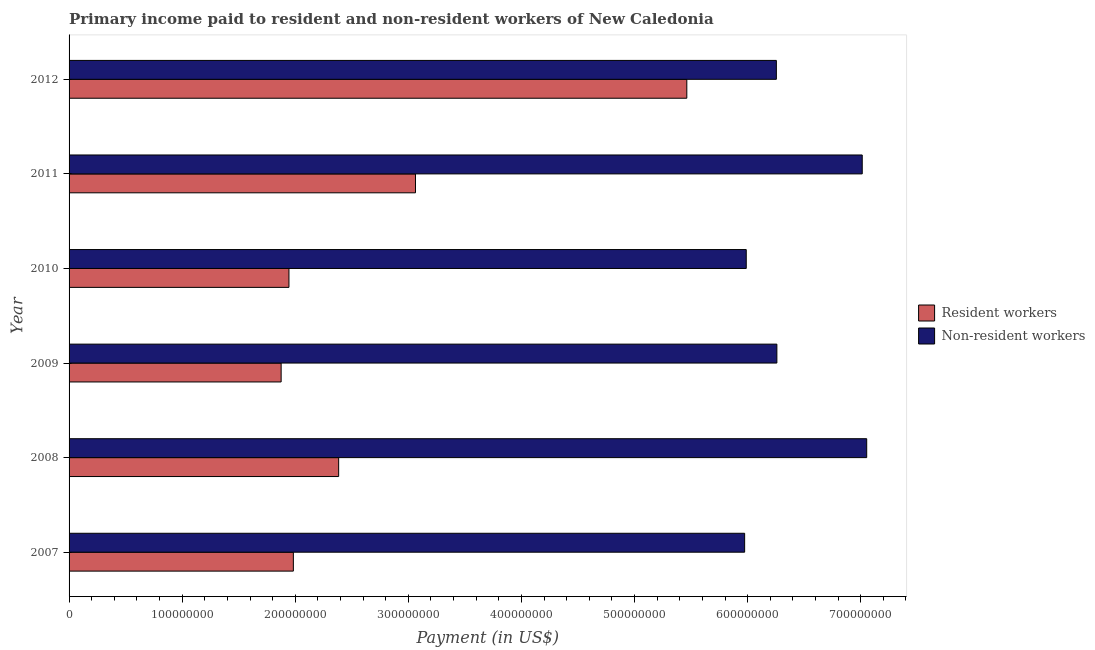How many different coloured bars are there?
Offer a very short reply. 2. How many groups of bars are there?
Give a very brief answer. 6. Are the number of bars per tick equal to the number of legend labels?
Provide a succinct answer. Yes. Are the number of bars on each tick of the Y-axis equal?
Your answer should be compact. Yes. How many bars are there on the 2nd tick from the top?
Your answer should be compact. 2. How many bars are there on the 3rd tick from the bottom?
Your answer should be compact. 2. What is the label of the 4th group of bars from the top?
Provide a short and direct response. 2009. In how many cases, is the number of bars for a given year not equal to the number of legend labels?
Provide a short and direct response. 0. What is the payment made to resident workers in 2011?
Your answer should be very brief. 3.06e+08. Across all years, what is the maximum payment made to non-resident workers?
Your answer should be compact. 7.05e+08. Across all years, what is the minimum payment made to non-resident workers?
Ensure brevity in your answer.  5.97e+08. In which year was the payment made to resident workers maximum?
Offer a terse response. 2012. In which year was the payment made to resident workers minimum?
Offer a very short reply. 2009. What is the total payment made to non-resident workers in the graph?
Keep it short and to the point. 3.85e+09. What is the difference between the payment made to resident workers in 2011 and that in 2012?
Provide a short and direct response. -2.40e+08. What is the difference between the payment made to resident workers in 2010 and the payment made to non-resident workers in 2011?
Offer a terse response. -5.07e+08. What is the average payment made to non-resident workers per year?
Your answer should be compact. 6.42e+08. In the year 2007, what is the difference between the payment made to non-resident workers and payment made to resident workers?
Keep it short and to the point. 3.99e+08. In how many years, is the payment made to resident workers greater than 500000000 US$?
Ensure brevity in your answer.  1. What is the ratio of the payment made to non-resident workers in 2008 to that in 2011?
Provide a short and direct response. 1.01. Is the payment made to resident workers in 2010 less than that in 2011?
Your answer should be very brief. Yes. Is the difference between the payment made to non-resident workers in 2010 and 2011 greater than the difference between the payment made to resident workers in 2010 and 2011?
Offer a terse response. Yes. What is the difference between the highest and the second highest payment made to non-resident workers?
Offer a very short reply. 3.95e+06. What is the difference between the highest and the lowest payment made to resident workers?
Ensure brevity in your answer.  3.59e+08. Is the sum of the payment made to non-resident workers in 2007 and 2012 greater than the maximum payment made to resident workers across all years?
Make the answer very short. Yes. What does the 1st bar from the top in 2009 represents?
Keep it short and to the point. Non-resident workers. What does the 1st bar from the bottom in 2012 represents?
Offer a very short reply. Resident workers. How many bars are there?
Your answer should be compact. 12. Are all the bars in the graph horizontal?
Keep it short and to the point. Yes. Are the values on the major ticks of X-axis written in scientific E-notation?
Your response must be concise. No. How many legend labels are there?
Ensure brevity in your answer.  2. How are the legend labels stacked?
Provide a short and direct response. Vertical. What is the title of the graph?
Give a very brief answer. Primary income paid to resident and non-resident workers of New Caledonia. Does "Measles" appear as one of the legend labels in the graph?
Provide a succinct answer. No. What is the label or title of the X-axis?
Give a very brief answer. Payment (in US$). What is the Payment (in US$) of Resident workers in 2007?
Offer a terse response. 1.98e+08. What is the Payment (in US$) of Non-resident workers in 2007?
Give a very brief answer. 5.97e+08. What is the Payment (in US$) in Resident workers in 2008?
Your answer should be compact. 2.38e+08. What is the Payment (in US$) in Non-resident workers in 2008?
Provide a succinct answer. 7.05e+08. What is the Payment (in US$) of Resident workers in 2009?
Ensure brevity in your answer.  1.88e+08. What is the Payment (in US$) of Non-resident workers in 2009?
Provide a short and direct response. 6.26e+08. What is the Payment (in US$) in Resident workers in 2010?
Provide a succinct answer. 1.94e+08. What is the Payment (in US$) in Non-resident workers in 2010?
Make the answer very short. 5.99e+08. What is the Payment (in US$) in Resident workers in 2011?
Keep it short and to the point. 3.06e+08. What is the Payment (in US$) in Non-resident workers in 2011?
Make the answer very short. 7.01e+08. What is the Payment (in US$) in Resident workers in 2012?
Your answer should be very brief. 5.46e+08. What is the Payment (in US$) in Non-resident workers in 2012?
Offer a very short reply. 6.25e+08. Across all years, what is the maximum Payment (in US$) of Resident workers?
Keep it short and to the point. 5.46e+08. Across all years, what is the maximum Payment (in US$) of Non-resident workers?
Offer a terse response. 7.05e+08. Across all years, what is the minimum Payment (in US$) of Resident workers?
Offer a very short reply. 1.88e+08. Across all years, what is the minimum Payment (in US$) in Non-resident workers?
Give a very brief answer. 5.97e+08. What is the total Payment (in US$) in Resident workers in the graph?
Provide a succinct answer. 1.67e+09. What is the total Payment (in US$) of Non-resident workers in the graph?
Keep it short and to the point. 3.85e+09. What is the difference between the Payment (in US$) of Resident workers in 2007 and that in 2008?
Your answer should be compact. -4.01e+07. What is the difference between the Payment (in US$) of Non-resident workers in 2007 and that in 2008?
Ensure brevity in your answer.  -1.08e+08. What is the difference between the Payment (in US$) of Resident workers in 2007 and that in 2009?
Offer a very short reply. 1.08e+07. What is the difference between the Payment (in US$) of Non-resident workers in 2007 and that in 2009?
Provide a succinct answer. -2.85e+07. What is the difference between the Payment (in US$) in Resident workers in 2007 and that in 2010?
Provide a short and direct response. 3.89e+06. What is the difference between the Payment (in US$) in Non-resident workers in 2007 and that in 2010?
Make the answer very short. -1.42e+06. What is the difference between the Payment (in US$) of Resident workers in 2007 and that in 2011?
Your answer should be very brief. -1.08e+08. What is the difference between the Payment (in US$) of Non-resident workers in 2007 and that in 2011?
Your response must be concise. -1.04e+08. What is the difference between the Payment (in US$) of Resident workers in 2007 and that in 2012?
Ensure brevity in your answer.  -3.48e+08. What is the difference between the Payment (in US$) in Non-resident workers in 2007 and that in 2012?
Ensure brevity in your answer.  -2.80e+07. What is the difference between the Payment (in US$) of Resident workers in 2008 and that in 2009?
Make the answer very short. 5.09e+07. What is the difference between the Payment (in US$) in Non-resident workers in 2008 and that in 2009?
Offer a terse response. 7.94e+07. What is the difference between the Payment (in US$) in Resident workers in 2008 and that in 2010?
Give a very brief answer. 4.39e+07. What is the difference between the Payment (in US$) in Non-resident workers in 2008 and that in 2010?
Ensure brevity in your answer.  1.07e+08. What is the difference between the Payment (in US$) of Resident workers in 2008 and that in 2011?
Make the answer very short. -6.79e+07. What is the difference between the Payment (in US$) in Non-resident workers in 2008 and that in 2011?
Keep it short and to the point. 3.95e+06. What is the difference between the Payment (in US$) of Resident workers in 2008 and that in 2012?
Your answer should be very brief. -3.08e+08. What is the difference between the Payment (in US$) in Non-resident workers in 2008 and that in 2012?
Offer a terse response. 7.99e+07. What is the difference between the Payment (in US$) in Resident workers in 2009 and that in 2010?
Offer a very short reply. -6.91e+06. What is the difference between the Payment (in US$) of Non-resident workers in 2009 and that in 2010?
Make the answer very short. 2.71e+07. What is the difference between the Payment (in US$) in Resident workers in 2009 and that in 2011?
Give a very brief answer. -1.19e+08. What is the difference between the Payment (in US$) in Non-resident workers in 2009 and that in 2011?
Your response must be concise. -7.55e+07. What is the difference between the Payment (in US$) in Resident workers in 2009 and that in 2012?
Your answer should be compact. -3.59e+08. What is the difference between the Payment (in US$) in Non-resident workers in 2009 and that in 2012?
Your answer should be compact. 4.55e+05. What is the difference between the Payment (in US$) of Resident workers in 2010 and that in 2011?
Provide a short and direct response. -1.12e+08. What is the difference between the Payment (in US$) in Non-resident workers in 2010 and that in 2011?
Provide a succinct answer. -1.03e+08. What is the difference between the Payment (in US$) of Resident workers in 2010 and that in 2012?
Your answer should be compact. -3.52e+08. What is the difference between the Payment (in US$) of Non-resident workers in 2010 and that in 2012?
Ensure brevity in your answer.  -2.66e+07. What is the difference between the Payment (in US$) of Resident workers in 2011 and that in 2012?
Make the answer very short. -2.40e+08. What is the difference between the Payment (in US$) of Non-resident workers in 2011 and that in 2012?
Provide a short and direct response. 7.59e+07. What is the difference between the Payment (in US$) in Resident workers in 2007 and the Payment (in US$) in Non-resident workers in 2008?
Your answer should be compact. -5.07e+08. What is the difference between the Payment (in US$) in Resident workers in 2007 and the Payment (in US$) in Non-resident workers in 2009?
Give a very brief answer. -4.28e+08. What is the difference between the Payment (in US$) of Resident workers in 2007 and the Payment (in US$) of Non-resident workers in 2010?
Give a very brief answer. -4.00e+08. What is the difference between the Payment (in US$) of Resident workers in 2007 and the Payment (in US$) of Non-resident workers in 2011?
Provide a short and direct response. -5.03e+08. What is the difference between the Payment (in US$) of Resident workers in 2007 and the Payment (in US$) of Non-resident workers in 2012?
Provide a succinct answer. -4.27e+08. What is the difference between the Payment (in US$) of Resident workers in 2008 and the Payment (in US$) of Non-resident workers in 2009?
Your response must be concise. -3.87e+08. What is the difference between the Payment (in US$) of Resident workers in 2008 and the Payment (in US$) of Non-resident workers in 2010?
Keep it short and to the point. -3.60e+08. What is the difference between the Payment (in US$) of Resident workers in 2008 and the Payment (in US$) of Non-resident workers in 2011?
Make the answer very short. -4.63e+08. What is the difference between the Payment (in US$) in Resident workers in 2008 and the Payment (in US$) in Non-resident workers in 2012?
Keep it short and to the point. -3.87e+08. What is the difference between the Payment (in US$) of Resident workers in 2009 and the Payment (in US$) of Non-resident workers in 2010?
Offer a terse response. -4.11e+08. What is the difference between the Payment (in US$) of Resident workers in 2009 and the Payment (in US$) of Non-resident workers in 2011?
Keep it short and to the point. -5.14e+08. What is the difference between the Payment (in US$) in Resident workers in 2009 and the Payment (in US$) in Non-resident workers in 2012?
Ensure brevity in your answer.  -4.38e+08. What is the difference between the Payment (in US$) of Resident workers in 2010 and the Payment (in US$) of Non-resident workers in 2011?
Provide a succinct answer. -5.07e+08. What is the difference between the Payment (in US$) of Resident workers in 2010 and the Payment (in US$) of Non-resident workers in 2012?
Offer a terse response. -4.31e+08. What is the difference between the Payment (in US$) of Resident workers in 2011 and the Payment (in US$) of Non-resident workers in 2012?
Your response must be concise. -3.19e+08. What is the average Payment (in US$) of Resident workers per year?
Give a very brief answer. 2.79e+08. What is the average Payment (in US$) of Non-resident workers per year?
Your answer should be compact. 6.42e+08. In the year 2007, what is the difference between the Payment (in US$) in Resident workers and Payment (in US$) in Non-resident workers?
Offer a terse response. -3.99e+08. In the year 2008, what is the difference between the Payment (in US$) in Resident workers and Payment (in US$) in Non-resident workers?
Offer a very short reply. -4.67e+08. In the year 2009, what is the difference between the Payment (in US$) in Resident workers and Payment (in US$) in Non-resident workers?
Offer a terse response. -4.38e+08. In the year 2010, what is the difference between the Payment (in US$) in Resident workers and Payment (in US$) in Non-resident workers?
Your response must be concise. -4.04e+08. In the year 2011, what is the difference between the Payment (in US$) in Resident workers and Payment (in US$) in Non-resident workers?
Your answer should be very brief. -3.95e+08. In the year 2012, what is the difference between the Payment (in US$) of Resident workers and Payment (in US$) of Non-resident workers?
Ensure brevity in your answer.  -7.92e+07. What is the ratio of the Payment (in US$) of Resident workers in 2007 to that in 2008?
Offer a very short reply. 0.83. What is the ratio of the Payment (in US$) in Non-resident workers in 2007 to that in 2008?
Your answer should be compact. 0.85. What is the ratio of the Payment (in US$) of Resident workers in 2007 to that in 2009?
Your answer should be very brief. 1.06. What is the ratio of the Payment (in US$) in Non-resident workers in 2007 to that in 2009?
Your answer should be compact. 0.95. What is the ratio of the Payment (in US$) of Resident workers in 2007 to that in 2010?
Your answer should be compact. 1.02. What is the ratio of the Payment (in US$) of Resident workers in 2007 to that in 2011?
Offer a very short reply. 0.65. What is the ratio of the Payment (in US$) of Non-resident workers in 2007 to that in 2011?
Offer a very short reply. 0.85. What is the ratio of the Payment (in US$) in Resident workers in 2007 to that in 2012?
Your response must be concise. 0.36. What is the ratio of the Payment (in US$) in Non-resident workers in 2007 to that in 2012?
Your answer should be very brief. 0.96. What is the ratio of the Payment (in US$) of Resident workers in 2008 to that in 2009?
Your answer should be compact. 1.27. What is the ratio of the Payment (in US$) in Non-resident workers in 2008 to that in 2009?
Your answer should be compact. 1.13. What is the ratio of the Payment (in US$) in Resident workers in 2008 to that in 2010?
Give a very brief answer. 1.23. What is the ratio of the Payment (in US$) of Non-resident workers in 2008 to that in 2010?
Offer a very short reply. 1.18. What is the ratio of the Payment (in US$) in Resident workers in 2008 to that in 2011?
Your response must be concise. 0.78. What is the ratio of the Payment (in US$) of Non-resident workers in 2008 to that in 2011?
Provide a succinct answer. 1.01. What is the ratio of the Payment (in US$) of Resident workers in 2008 to that in 2012?
Your answer should be compact. 0.44. What is the ratio of the Payment (in US$) of Non-resident workers in 2008 to that in 2012?
Provide a short and direct response. 1.13. What is the ratio of the Payment (in US$) of Resident workers in 2009 to that in 2010?
Your answer should be very brief. 0.96. What is the ratio of the Payment (in US$) of Non-resident workers in 2009 to that in 2010?
Make the answer very short. 1.05. What is the ratio of the Payment (in US$) of Resident workers in 2009 to that in 2011?
Your response must be concise. 0.61. What is the ratio of the Payment (in US$) of Non-resident workers in 2009 to that in 2011?
Provide a succinct answer. 0.89. What is the ratio of the Payment (in US$) of Resident workers in 2009 to that in 2012?
Offer a terse response. 0.34. What is the ratio of the Payment (in US$) of Resident workers in 2010 to that in 2011?
Provide a short and direct response. 0.63. What is the ratio of the Payment (in US$) in Non-resident workers in 2010 to that in 2011?
Keep it short and to the point. 0.85. What is the ratio of the Payment (in US$) of Resident workers in 2010 to that in 2012?
Your answer should be very brief. 0.36. What is the ratio of the Payment (in US$) of Non-resident workers in 2010 to that in 2012?
Ensure brevity in your answer.  0.96. What is the ratio of the Payment (in US$) of Resident workers in 2011 to that in 2012?
Ensure brevity in your answer.  0.56. What is the ratio of the Payment (in US$) in Non-resident workers in 2011 to that in 2012?
Provide a succinct answer. 1.12. What is the difference between the highest and the second highest Payment (in US$) of Resident workers?
Your response must be concise. 2.40e+08. What is the difference between the highest and the second highest Payment (in US$) of Non-resident workers?
Offer a very short reply. 3.95e+06. What is the difference between the highest and the lowest Payment (in US$) of Resident workers?
Your response must be concise. 3.59e+08. What is the difference between the highest and the lowest Payment (in US$) in Non-resident workers?
Your answer should be very brief. 1.08e+08. 